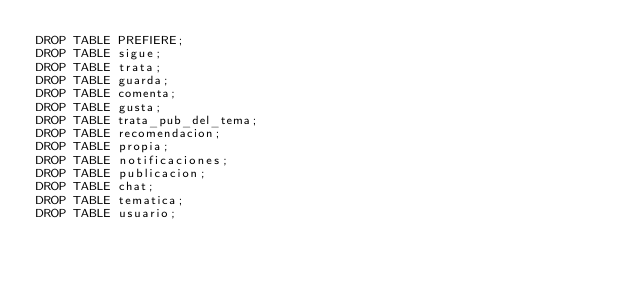<code> <loc_0><loc_0><loc_500><loc_500><_SQL_>DROP TABLE PREFIERE;
DROP TABLE sigue;
DROP TABLE trata;
DROP TABLE guarda;
DROP TABLE comenta;
DROP TABLE gusta;
DROP TABLE trata_pub_del_tema;
DROP TABLE recomendacion;
DROP TABLE propia;
DROP TABLE notificaciones;
DROP TABLE publicacion;
DROP TABLE chat;
DROP TABLE tematica;
DROP TABLE usuario;</code> 